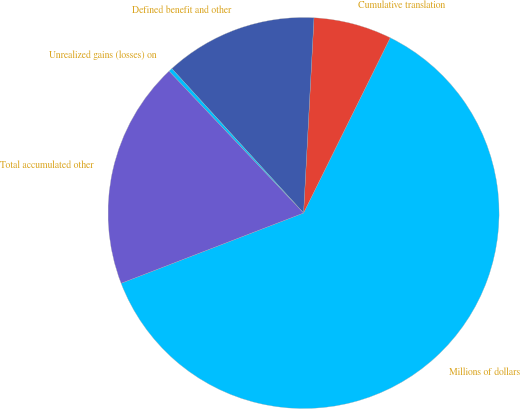Convert chart to OTSL. <chart><loc_0><loc_0><loc_500><loc_500><pie_chart><fcel>Millions of dollars<fcel>Cumulative translation<fcel>Defined benefit and other<fcel>Unrealized gains (losses) on<fcel>Total accumulated other<nl><fcel>61.84%<fcel>6.46%<fcel>12.62%<fcel>0.31%<fcel>18.77%<nl></chart> 